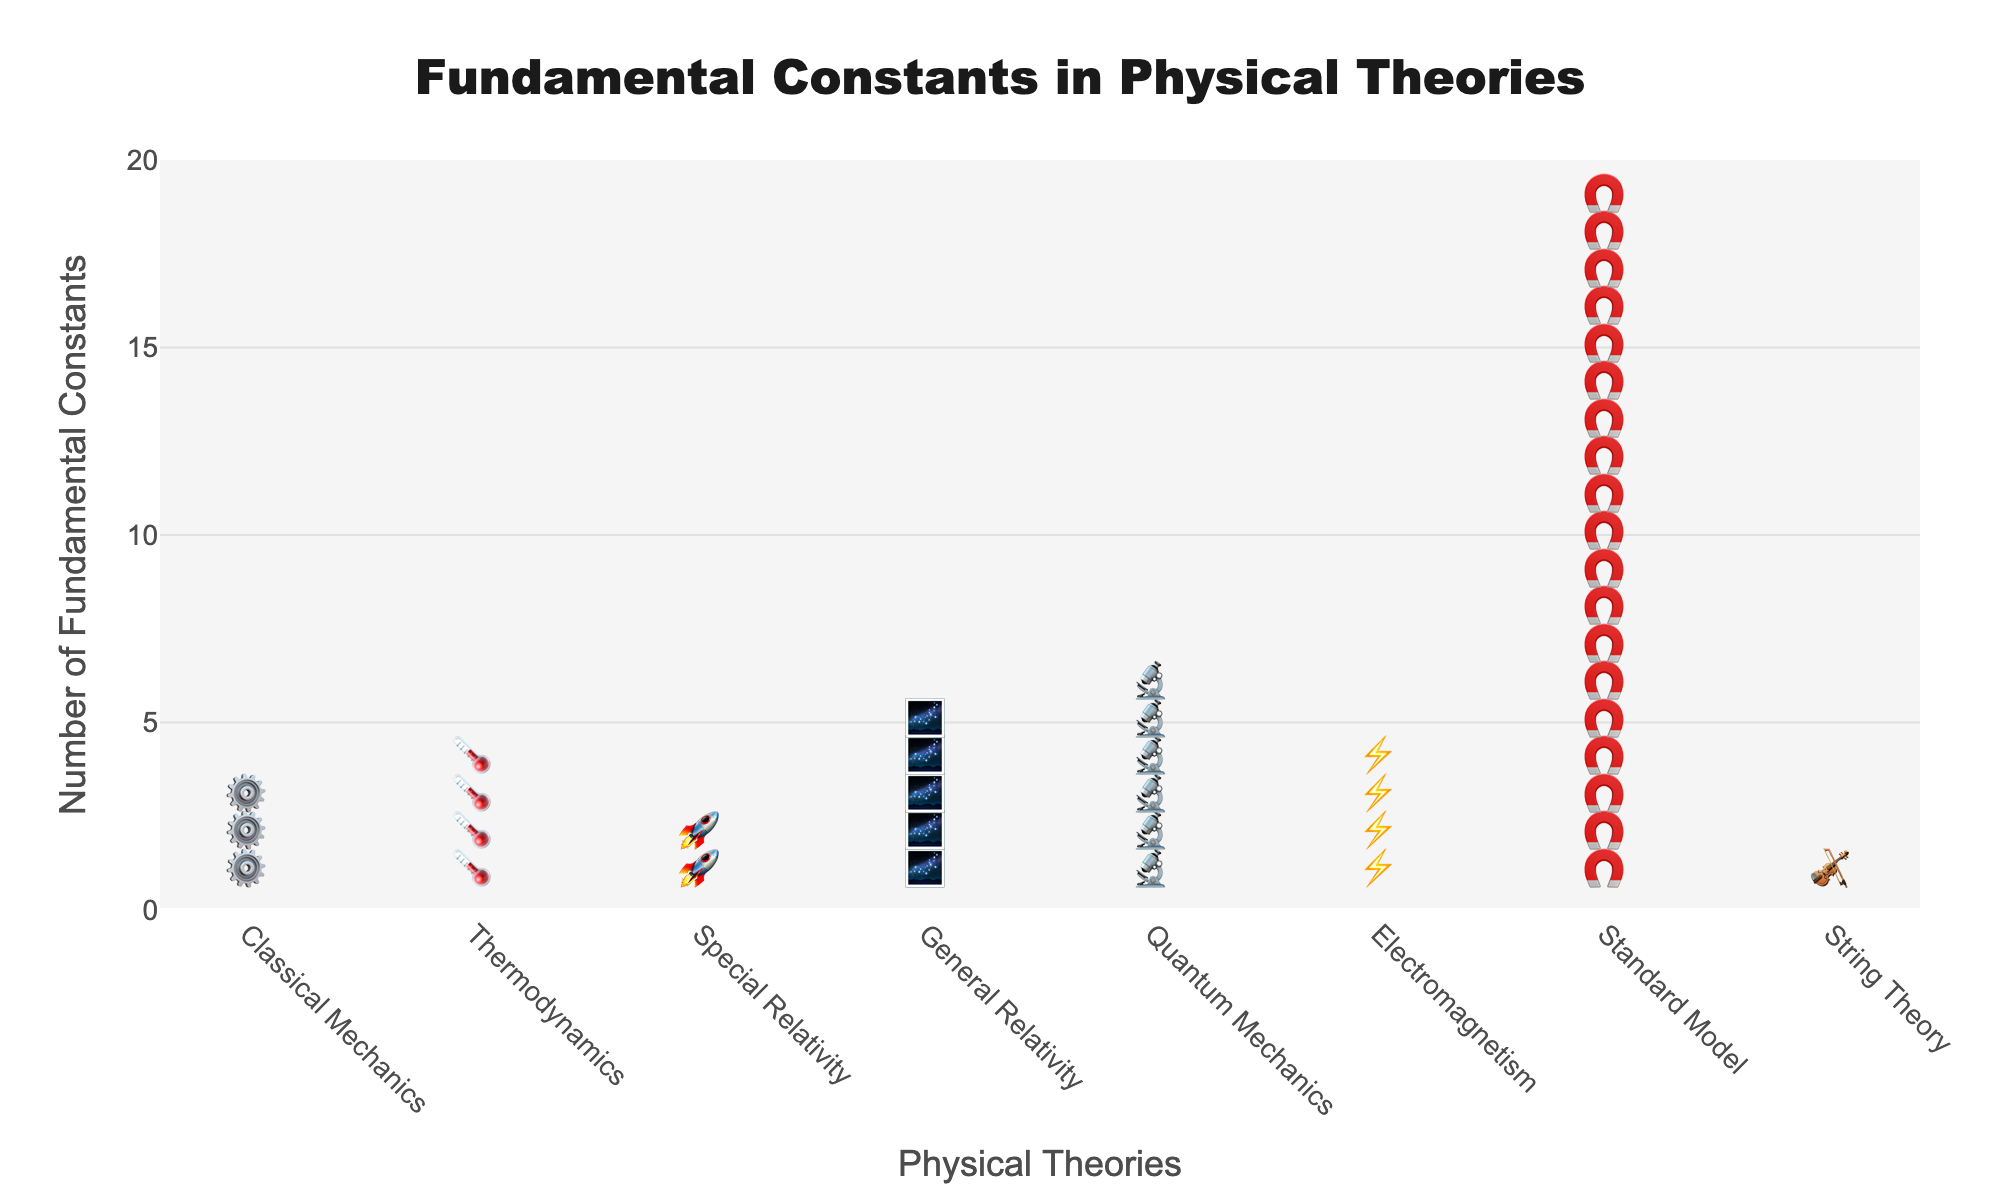What's the title of the figure? The title is displayed prominently at the top of the figure. It provides context on what the figure is illustrating.
Answer: Fundamental Constants in Physical Theories Which theory has the highest number of fundamental constants? By examining the y-axis values and corresponding symbols, the theory with the tallest line of symbols has the highest number of constants.
Answer: Standard Model How many fundamental constants are used in General Relativity? The number of symbols on the General Relativity line represents the number of fundamental constants. Count these symbols.
Answer: 5 Which theory uses fewer fundamental constants, Special Relativity or Classical Mechanics? Compare the number of symbols for Special Relativity (🚀) and Classical Mechanics (⚙️). The theory with fewer symbols uses fewer constants.
Answer: Special Relativity What's the total number of fundamental constants for Classical Mechanics and Thermodynamics combined? Add the number of constants for Classical Mechanics (3) and Thermodynamics (4).
Answer: 7 Which theory uses exactly four fundamental constants? Identify the theory with symbols in a line of length four.
Answer: Thermodynamics and Electromagnetism How many more fundamental constants does Quantum Mechanics use compared to Special Relativity? Subtract the number of constants in Special Relativity (2) from those in Quantum Mechanics (6).
Answer: 4 How many theories use fewer than five fundamental constants? Count the number of theories (lines of symbols) where the number of symbols is less than five.
Answer: 5 Which theory is represented by the violin symbol in the figure? Locate the violin symbol (🎻) in the figure and note the associated theory.
Answer: String Theory What is the average number of fundamental constants used by the theories listed? Add the number of constants for all theories and divide by the number of theories. Calculation: (3 + 4 + 2 + 5 + 6 + 4 + 19 + 1) / 8 = 5.5
Answer: 5.5 